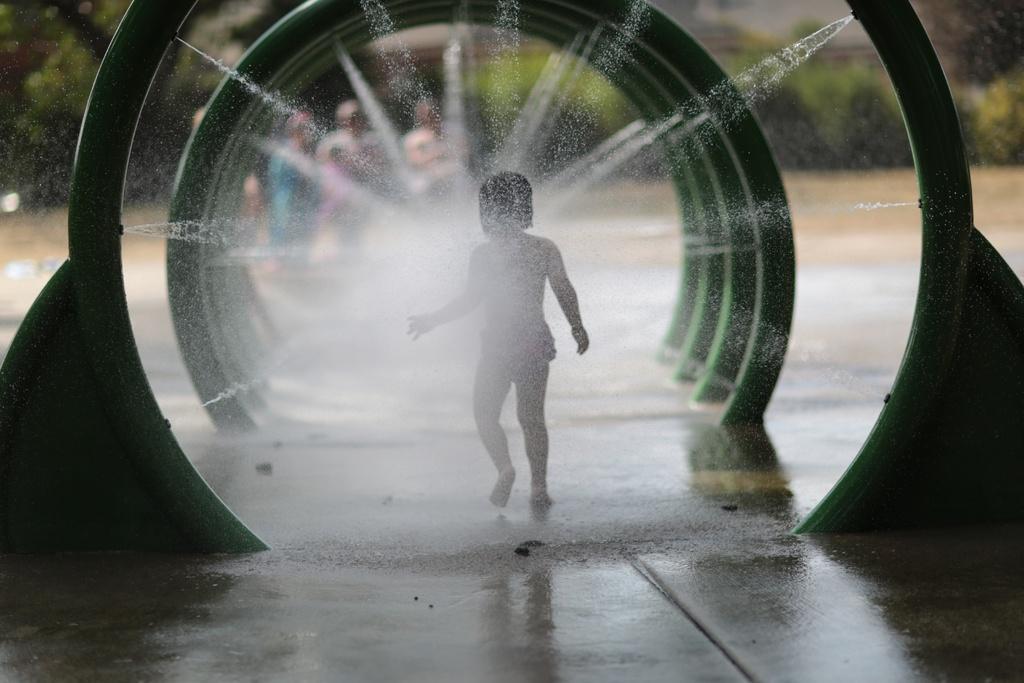Describe this image in one or two sentences. In the middle I can see a person, metal rods and water. In the background I can see a group of people are standing on the road, trees and the sky. This image is taken may be during a day. 